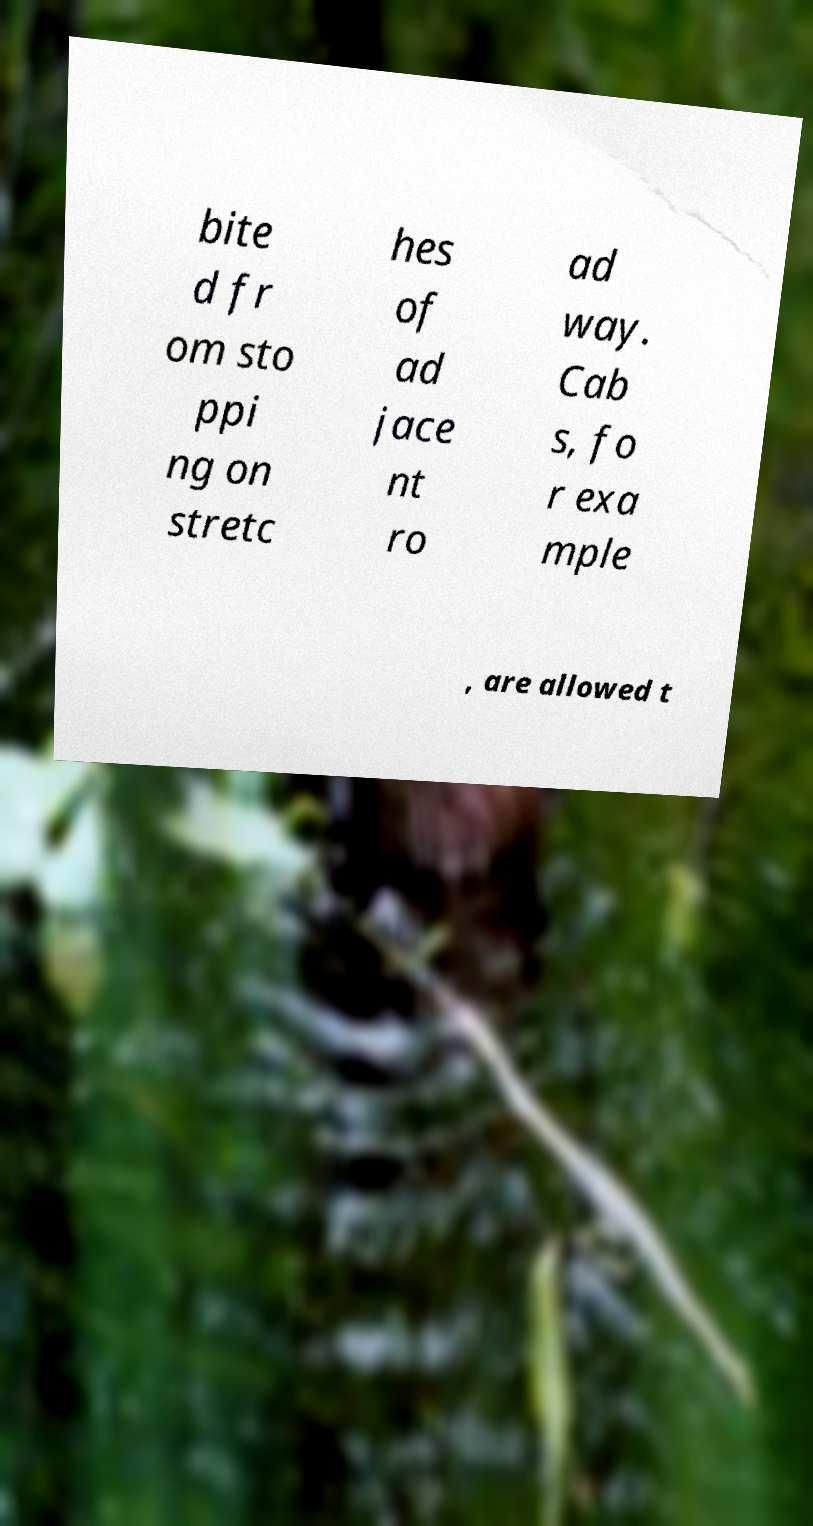There's text embedded in this image that I need extracted. Can you transcribe it verbatim? bite d fr om sto ppi ng on stretc hes of ad jace nt ro ad way. Cab s, fo r exa mple , are allowed t 